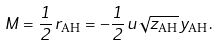Convert formula to latex. <formula><loc_0><loc_0><loc_500><loc_500>M = \frac { 1 } { 2 } \, r _ { \text {AH} } = - \frac { 1 } { 2 } \, u \sqrt { z _ { \text {AH} } } \, y _ { \text {AH} } .</formula> 